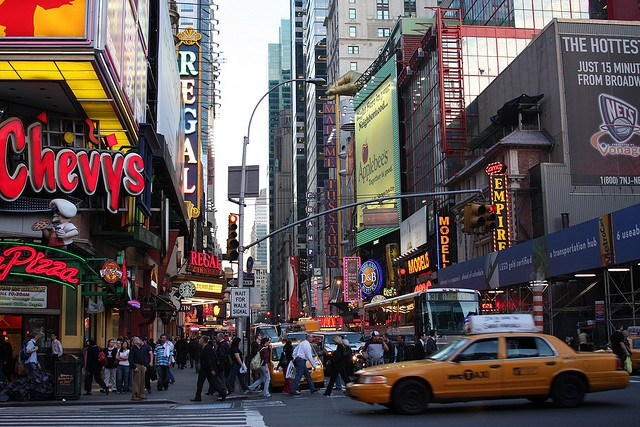Describe the objects in this image and their specific colors. I can see car in orange, black, maroon, brown, and gray tones, people in orange, black, gray, and maroon tones, bus in orange, black, gray, maroon, and blue tones, car in orange, black, maroon, and brown tones, and traffic light in orange, black, maroon, and gray tones in this image. 